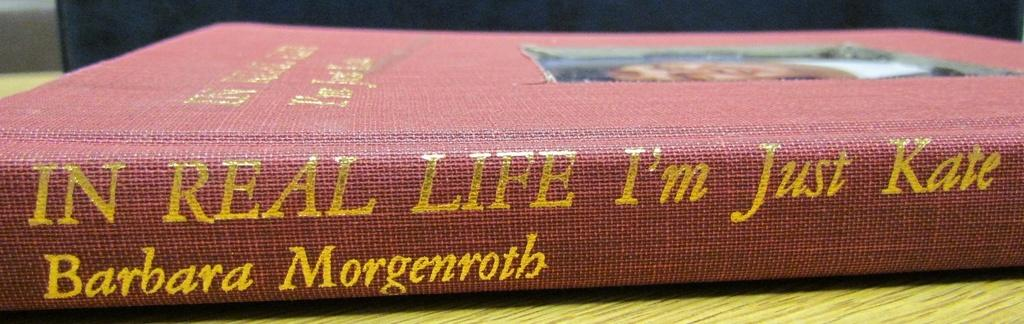<image>
Summarize the visual content of the image. A red hardbound book called "In Real Life I'm Just Kate" by Morgenroth. 